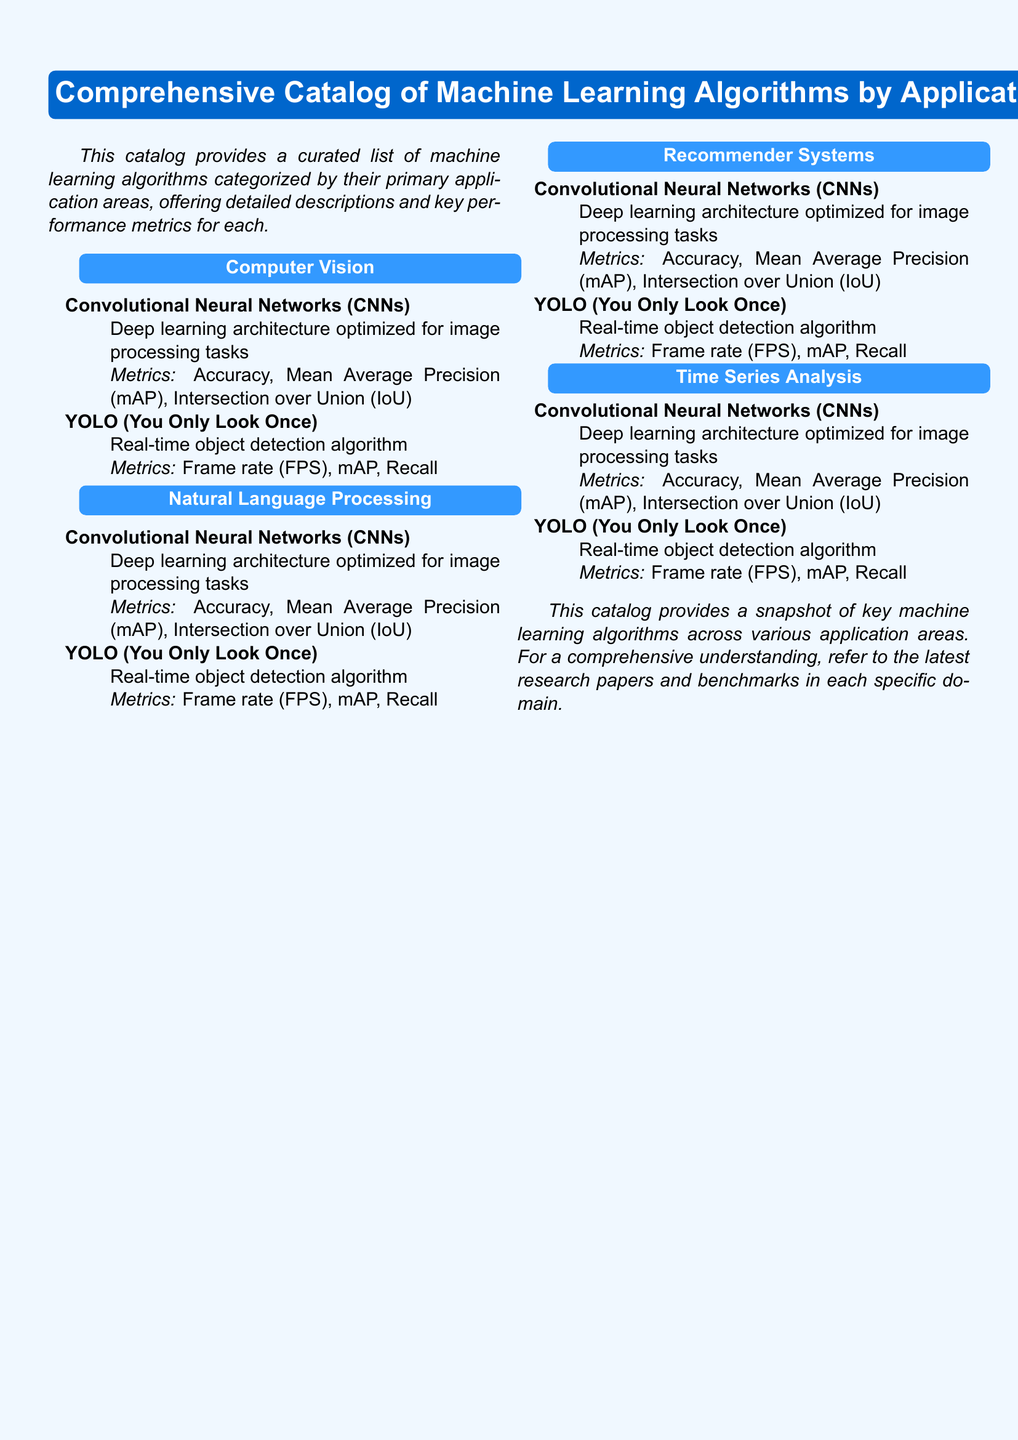What are the primary application areas covered in the catalog? The document lists the application areas under which machine learning algorithms are categorized, specifically, Computer Vision, Natural Language Processing, Recommender Systems, and Time Series Analysis.
Answer: Computer Vision, Natural Language Processing, Recommender Systems, Time Series Analysis What is the primary purpose of Convolutional Neural Networks? The document states that Convolutional Neural Networks (CNNs) are optimized for image processing tasks.
Answer: Image processing tasks What metric is associated with the YOLO algorithm? The catalog describes three metrics linked to the performance evaluation of the YOLO algorithm. One of them is Recall.
Answer: Recall What is the fill color for the category titles in the document? The document specifies a color code for the category titles, which is RGB 51,153,255.
Answer: RGB 51,153,255 How many machine learning algorithms are mentioned under Computer Vision? The document lists two algorithms specifically categorized under Computer Vision.
Answer: Two 